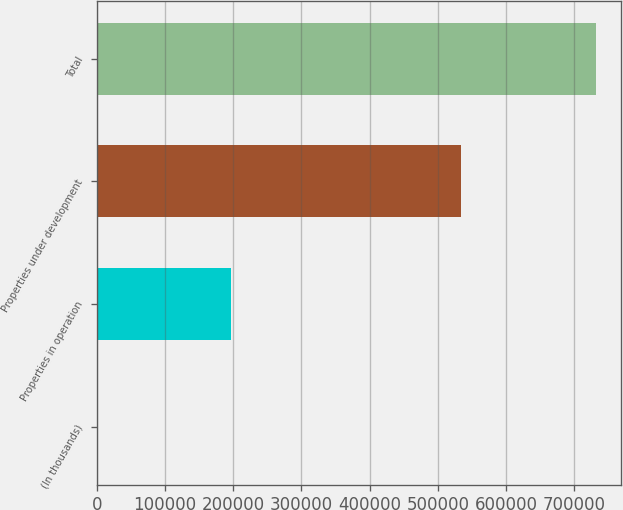Convert chart. <chart><loc_0><loc_0><loc_500><loc_500><bar_chart><fcel>(In thousands)<fcel>Properties in operation<fcel>Properties under development<fcel>Total<nl><fcel>2014<fcel>196980<fcel>534632<fcel>731612<nl></chart> 